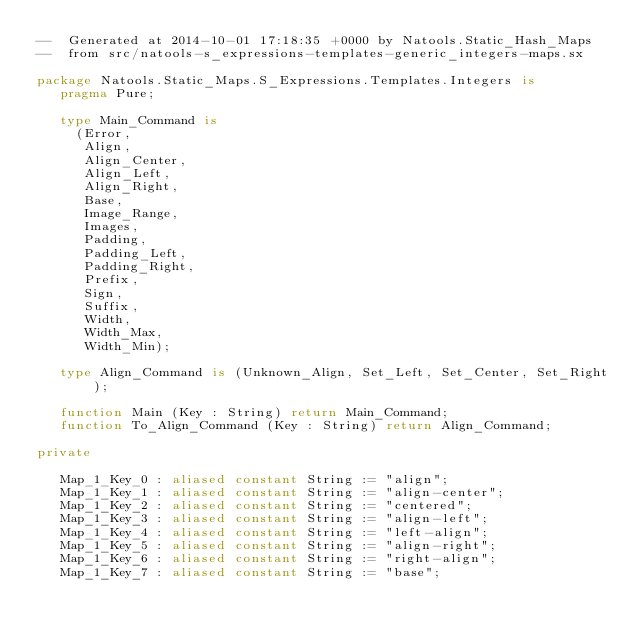Convert code to text. <code><loc_0><loc_0><loc_500><loc_500><_Ada_>--  Generated at 2014-10-01 17:18:35 +0000 by Natools.Static_Hash_Maps
--  from src/natools-s_expressions-templates-generic_integers-maps.sx

package Natools.Static_Maps.S_Expressions.Templates.Integers is
   pragma Pure;

   type Main_Command is
     (Error,
      Align,
      Align_Center,
      Align_Left,
      Align_Right,
      Base,
      Image_Range,
      Images,
      Padding,
      Padding_Left,
      Padding_Right,
      Prefix,
      Sign,
      Suffix,
      Width,
      Width_Max,
      Width_Min);

   type Align_Command is (Unknown_Align, Set_Left, Set_Center, Set_Right);

   function Main (Key : String) return Main_Command;
   function To_Align_Command (Key : String) return Align_Command;

private

   Map_1_Key_0 : aliased constant String := "align";
   Map_1_Key_1 : aliased constant String := "align-center";
   Map_1_Key_2 : aliased constant String := "centered";
   Map_1_Key_3 : aliased constant String := "align-left";
   Map_1_Key_4 : aliased constant String := "left-align";
   Map_1_Key_5 : aliased constant String := "align-right";
   Map_1_Key_6 : aliased constant String := "right-align";
   Map_1_Key_7 : aliased constant String := "base";</code> 